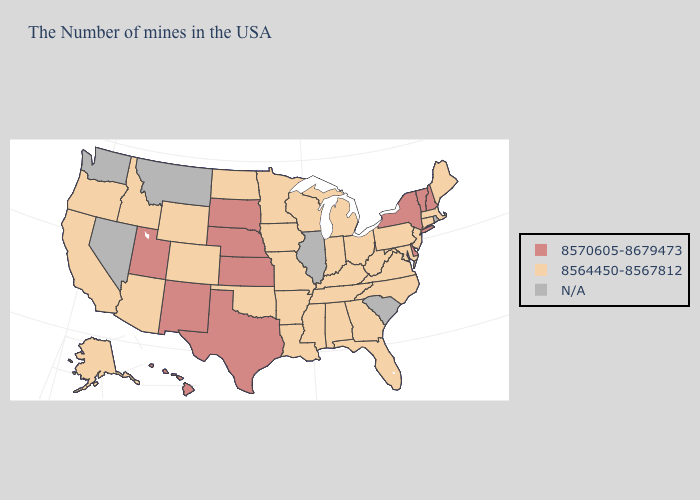How many symbols are there in the legend?
Keep it brief. 3. Name the states that have a value in the range N/A?
Concise answer only. Rhode Island, South Carolina, Illinois, Montana, Nevada, Washington. What is the value of Kentucky?
Concise answer only. 8564450-8567812. Among the states that border Missouri , does Kansas have the lowest value?
Concise answer only. No. Does Virginia have the lowest value in the USA?
Write a very short answer. Yes. What is the value of Oklahoma?
Be succinct. 8564450-8567812. What is the value of Alabama?
Write a very short answer. 8564450-8567812. Name the states that have a value in the range N/A?
Quick response, please. Rhode Island, South Carolina, Illinois, Montana, Nevada, Washington. What is the highest value in the Northeast ?
Concise answer only. 8570605-8679473. Name the states that have a value in the range 8570605-8679473?
Quick response, please. New Hampshire, Vermont, New York, Delaware, Kansas, Nebraska, Texas, South Dakota, New Mexico, Utah, Hawaii. Among the states that border Oklahoma , does Kansas have the lowest value?
Be succinct. No. Name the states that have a value in the range 8564450-8567812?
Short answer required. Maine, Massachusetts, Connecticut, New Jersey, Maryland, Pennsylvania, Virginia, North Carolina, West Virginia, Ohio, Florida, Georgia, Michigan, Kentucky, Indiana, Alabama, Tennessee, Wisconsin, Mississippi, Louisiana, Missouri, Arkansas, Minnesota, Iowa, Oklahoma, North Dakota, Wyoming, Colorado, Arizona, Idaho, California, Oregon, Alaska. Does Arkansas have the highest value in the South?
Concise answer only. No. How many symbols are there in the legend?
Keep it brief. 3. Name the states that have a value in the range 8570605-8679473?
Answer briefly. New Hampshire, Vermont, New York, Delaware, Kansas, Nebraska, Texas, South Dakota, New Mexico, Utah, Hawaii. 